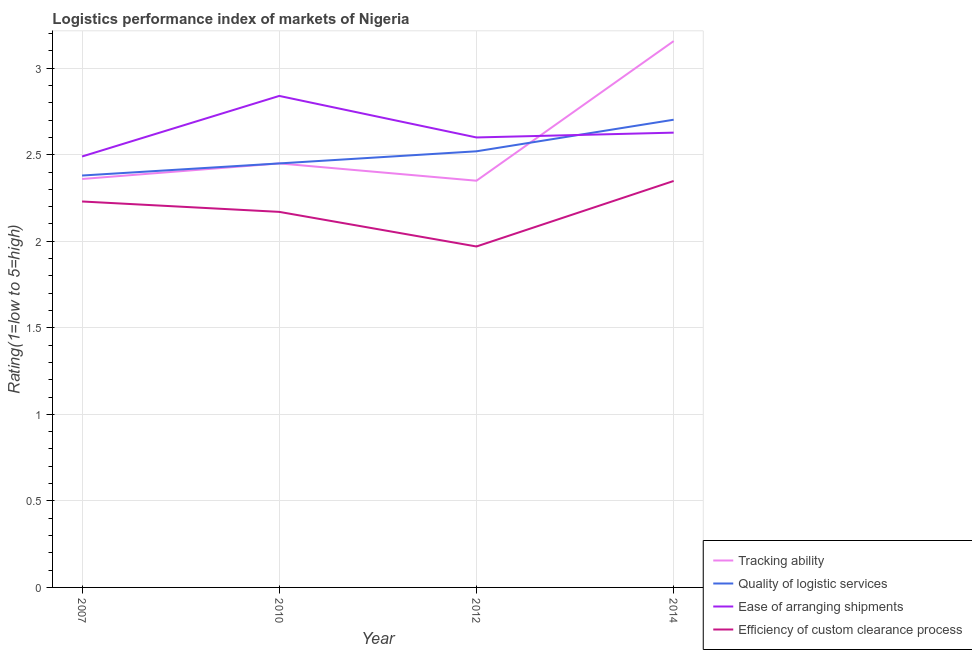What is the lpi rating of tracking ability in 2010?
Keep it short and to the point. 2.45. Across all years, what is the maximum lpi rating of quality of logistic services?
Ensure brevity in your answer.  2.7. Across all years, what is the minimum lpi rating of ease of arranging shipments?
Give a very brief answer. 2.49. In which year was the lpi rating of efficiency of custom clearance process maximum?
Give a very brief answer. 2014. In which year was the lpi rating of efficiency of custom clearance process minimum?
Your answer should be compact. 2012. What is the total lpi rating of ease of arranging shipments in the graph?
Give a very brief answer. 10.56. What is the difference between the lpi rating of quality of logistic services in 2012 and that in 2014?
Keep it short and to the point. -0.18. What is the difference between the lpi rating of efficiency of custom clearance process in 2014 and the lpi rating of ease of arranging shipments in 2007?
Make the answer very short. -0.14. What is the average lpi rating of tracking ability per year?
Give a very brief answer. 2.58. In the year 2014, what is the difference between the lpi rating of efficiency of custom clearance process and lpi rating of tracking ability?
Keep it short and to the point. -0.81. In how many years, is the lpi rating of efficiency of custom clearance process greater than 2?
Provide a succinct answer. 3. What is the ratio of the lpi rating of quality of logistic services in 2007 to that in 2014?
Offer a very short reply. 0.88. Is the lpi rating of tracking ability in 2007 less than that in 2010?
Ensure brevity in your answer.  Yes. Is the difference between the lpi rating of efficiency of custom clearance process in 2010 and 2012 greater than the difference between the lpi rating of ease of arranging shipments in 2010 and 2012?
Provide a succinct answer. No. What is the difference between the highest and the second highest lpi rating of quality of logistic services?
Give a very brief answer. 0.18. What is the difference between the highest and the lowest lpi rating of ease of arranging shipments?
Give a very brief answer. 0.35. Is the sum of the lpi rating of quality of logistic services in 2012 and 2014 greater than the maximum lpi rating of tracking ability across all years?
Your answer should be compact. Yes. Is the lpi rating of efficiency of custom clearance process strictly greater than the lpi rating of ease of arranging shipments over the years?
Ensure brevity in your answer.  No. How many lines are there?
Your answer should be very brief. 4. Does the graph contain any zero values?
Provide a succinct answer. No. How many legend labels are there?
Make the answer very short. 4. How are the legend labels stacked?
Offer a very short reply. Vertical. What is the title of the graph?
Provide a succinct answer. Logistics performance index of markets of Nigeria. Does "Belgium" appear as one of the legend labels in the graph?
Give a very brief answer. No. What is the label or title of the Y-axis?
Give a very brief answer. Rating(1=low to 5=high). What is the Rating(1=low to 5=high) in Tracking ability in 2007?
Make the answer very short. 2.36. What is the Rating(1=low to 5=high) in Quality of logistic services in 2007?
Give a very brief answer. 2.38. What is the Rating(1=low to 5=high) of Ease of arranging shipments in 2007?
Your response must be concise. 2.49. What is the Rating(1=low to 5=high) of Efficiency of custom clearance process in 2007?
Give a very brief answer. 2.23. What is the Rating(1=low to 5=high) in Tracking ability in 2010?
Ensure brevity in your answer.  2.45. What is the Rating(1=low to 5=high) of Quality of logistic services in 2010?
Your answer should be compact. 2.45. What is the Rating(1=low to 5=high) in Ease of arranging shipments in 2010?
Give a very brief answer. 2.84. What is the Rating(1=low to 5=high) of Efficiency of custom clearance process in 2010?
Ensure brevity in your answer.  2.17. What is the Rating(1=low to 5=high) in Tracking ability in 2012?
Make the answer very short. 2.35. What is the Rating(1=low to 5=high) of Quality of logistic services in 2012?
Give a very brief answer. 2.52. What is the Rating(1=low to 5=high) of Ease of arranging shipments in 2012?
Keep it short and to the point. 2.6. What is the Rating(1=low to 5=high) of Efficiency of custom clearance process in 2012?
Provide a succinct answer. 1.97. What is the Rating(1=low to 5=high) of Tracking ability in 2014?
Provide a short and direct response. 3.16. What is the Rating(1=low to 5=high) of Quality of logistic services in 2014?
Make the answer very short. 2.7. What is the Rating(1=low to 5=high) of Ease of arranging shipments in 2014?
Your answer should be compact. 2.63. What is the Rating(1=low to 5=high) of Efficiency of custom clearance process in 2014?
Offer a very short reply. 2.35. Across all years, what is the maximum Rating(1=low to 5=high) of Tracking ability?
Offer a very short reply. 3.16. Across all years, what is the maximum Rating(1=low to 5=high) of Quality of logistic services?
Your answer should be very brief. 2.7. Across all years, what is the maximum Rating(1=low to 5=high) in Ease of arranging shipments?
Your answer should be compact. 2.84. Across all years, what is the maximum Rating(1=low to 5=high) in Efficiency of custom clearance process?
Provide a succinct answer. 2.35. Across all years, what is the minimum Rating(1=low to 5=high) in Tracking ability?
Keep it short and to the point. 2.35. Across all years, what is the minimum Rating(1=low to 5=high) in Quality of logistic services?
Offer a very short reply. 2.38. Across all years, what is the minimum Rating(1=low to 5=high) of Ease of arranging shipments?
Provide a short and direct response. 2.49. Across all years, what is the minimum Rating(1=low to 5=high) in Efficiency of custom clearance process?
Keep it short and to the point. 1.97. What is the total Rating(1=low to 5=high) in Tracking ability in the graph?
Provide a short and direct response. 10.32. What is the total Rating(1=low to 5=high) of Quality of logistic services in the graph?
Your response must be concise. 10.05. What is the total Rating(1=low to 5=high) of Ease of arranging shipments in the graph?
Provide a short and direct response. 10.56. What is the total Rating(1=low to 5=high) of Efficiency of custom clearance process in the graph?
Give a very brief answer. 8.72. What is the difference between the Rating(1=low to 5=high) in Tracking ability in 2007 and that in 2010?
Offer a very short reply. -0.09. What is the difference between the Rating(1=low to 5=high) in Quality of logistic services in 2007 and that in 2010?
Your answer should be very brief. -0.07. What is the difference between the Rating(1=low to 5=high) in Ease of arranging shipments in 2007 and that in 2010?
Provide a succinct answer. -0.35. What is the difference between the Rating(1=low to 5=high) of Tracking ability in 2007 and that in 2012?
Offer a very short reply. 0.01. What is the difference between the Rating(1=low to 5=high) of Quality of logistic services in 2007 and that in 2012?
Provide a short and direct response. -0.14. What is the difference between the Rating(1=low to 5=high) in Ease of arranging shipments in 2007 and that in 2012?
Provide a short and direct response. -0.11. What is the difference between the Rating(1=low to 5=high) in Efficiency of custom clearance process in 2007 and that in 2012?
Your answer should be compact. 0.26. What is the difference between the Rating(1=low to 5=high) in Tracking ability in 2007 and that in 2014?
Give a very brief answer. -0.8. What is the difference between the Rating(1=low to 5=high) in Quality of logistic services in 2007 and that in 2014?
Give a very brief answer. -0.32. What is the difference between the Rating(1=low to 5=high) of Ease of arranging shipments in 2007 and that in 2014?
Give a very brief answer. -0.14. What is the difference between the Rating(1=low to 5=high) of Efficiency of custom clearance process in 2007 and that in 2014?
Offer a terse response. -0.12. What is the difference between the Rating(1=low to 5=high) in Quality of logistic services in 2010 and that in 2012?
Your answer should be very brief. -0.07. What is the difference between the Rating(1=low to 5=high) of Ease of arranging shipments in 2010 and that in 2012?
Your answer should be very brief. 0.24. What is the difference between the Rating(1=low to 5=high) in Efficiency of custom clearance process in 2010 and that in 2012?
Your answer should be very brief. 0.2. What is the difference between the Rating(1=low to 5=high) in Tracking ability in 2010 and that in 2014?
Provide a succinct answer. -0.71. What is the difference between the Rating(1=low to 5=high) of Quality of logistic services in 2010 and that in 2014?
Offer a terse response. -0.25. What is the difference between the Rating(1=low to 5=high) of Ease of arranging shipments in 2010 and that in 2014?
Your response must be concise. 0.21. What is the difference between the Rating(1=low to 5=high) in Efficiency of custom clearance process in 2010 and that in 2014?
Offer a terse response. -0.18. What is the difference between the Rating(1=low to 5=high) in Tracking ability in 2012 and that in 2014?
Give a very brief answer. -0.81. What is the difference between the Rating(1=low to 5=high) in Quality of logistic services in 2012 and that in 2014?
Provide a succinct answer. -0.18. What is the difference between the Rating(1=low to 5=high) in Ease of arranging shipments in 2012 and that in 2014?
Keep it short and to the point. -0.03. What is the difference between the Rating(1=low to 5=high) of Efficiency of custom clearance process in 2012 and that in 2014?
Offer a very short reply. -0.38. What is the difference between the Rating(1=low to 5=high) in Tracking ability in 2007 and the Rating(1=low to 5=high) in Quality of logistic services in 2010?
Offer a very short reply. -0.09. What is the difference between the Rating(1=low to 5=high) of Tracking ability in 2007 and the Rating(1=low to 5=high) of Ease of arranging shipments in 2010?
Your response must be concise. -0.48. What is the difference between the Rating(1=low to 5=high) in Tracking ability in 2007 and the Rating(1=low to 5=high) in Efficiency of custom clearance process in 2010?
Your answer should be very brief. 0.19. What is the difference between the Rating(1=low to 5=high) of Quality of logistic services in 2007 and the Rating(1=low to 5=high) of Ease of arranging shipments in 2010?
Offer a very short reply. -0.46. What is the difference between the Rating(1=low to 5=high) of Quality of logistic services in 2007 and the Rating(1=low to 5=high) of Efficiency of custom clearance process in 2010?
Your answer should be compact. 0.21. What is the difference between the Rating(1=low to 5=high) in Ease of arranging shipments in 2007 and the Rating(1=low to 5=high) in Efficiency of custom clearance process in 2010?
Your response must be concise. 0.32. What is the difference between the Rating(1=low to 5=high) in Tracking ability in 2007 and the Rating(1=low to 5=high) in Quality of logistic services in 2012?
Your response must be concise. -0.16. What is the difference between the Rating(1=low to 5=high) in Tracking ability in 2007 and the Rating(1=low to 5=high) in Ease of arranging shipments in 2012?
Make the answer very short. -0.24. What is the difference between the Rating(1=low to 5=high) of Tracking ability in 2007 and the Rating(1=low to 5=high) of Efficiency of custom clearance process in 2012?
Give a very brief answer. 0.39. What is the difference between the Rating(1=low to 5=high) of Quality of logistic services in 2007 and the Rating(1=low to 5=high) of Ease of arranging shipments in 2012?
Make the answer very short. -0.22. What is the difference between the Rating(1=low to 5=high) in Quality of logistic services in 2007 and the Rating(1=low to 5=high) in Efficiency of custom clearance process in 2012?
Make the answer very short. 0.41. What is the difference between the Rating(1=low to 5=high) in Ease of arranging shipments in 2007 and the Rating(1=low to 5=high) in Efficiency of custom clearance process in 2012?
Provide a succinct answer. 0.52. What is the difference between the Rating(1=low to 5=high) in Tracking ability in 2007 and the Rating(1=low to 5=high) in Quality of logistic services in 2014?
Provide a short and direct response. -0.34. What is the difference between the Rating(1=low to 5=high) of Tracking ability in 2007 and the Rating(1=low to 5=high) of Ease of arranging shipments in 2014?
Ensure brevity in your answer.  -0.27. What is the difference between the Rating(1=low to 5=high) of Tracking ability in 2007 and the Rating(1=low to 5=high) of Efficiency of custom clearance process in 2014?
Give a very brief answer. 0.01. What is the difference between the Rating(1=low to 5=high) in Quality of logistic services in 2007 and the Rating(1=low to 5=high) in Ease of arranging shipments in 2014?
Give a very brief answer. -0.25. What is the difference between the Rating(1=low to 5=high) in Quality of logistic services in 2007 and the Rating(1=low to 5=high) in Efficiency of custom clearance process in 2014?
Your answer should be very brief. 0.03. What is the difference between the Rating(1=low to 5=high) of Ease of arranging shipments in 2007 and the Rating(1=low to 5=high) of Efficiency of custom clearance process in 2014?
Provide a succinct answer. 0.14. What is the difference between the Rating(1=low to 5=high) in Tracking ability in 2010 and the Rating(1=low to 5=high) in Quality of logistic services in 2012?
Your response must be concise. -0.07. What is the difference between the Rating(1=low to 5=high) in Tracking ability in 2010 and the Rating(1=low to 5=high) in Ease of arranging shipments in 2012?
Your answer should be compact. -0.15. What is the difference between the Rating(1=low to 5=high) of Tracking ability in 2010 and the Rating(1=low to 5=high) of Efficiency of custom clearance process in 2012?
Keep it short and to the point. 0.48. What is the difference between the Rating(1=low to 5=high) in Quality of logistic services in 2010 and the Rating(1=low to 5=high) in Efficiency of custom clearance process in 2012?
Provide a succinct answer. 0.48. What is the difference between the Rating(1=low to 5=high) in Ease of arranging shipments in 2010 and the Rating(1=low to 5=high) in Efficiency of custom clearance process in 2012?
Offer a terse response. 0.87. What is the difference between the Rating(1=low to 5=high) in Tracking ability in 2010 and the Rating(1=low to 5=high) in Quality of logistic services in 2014?
Your answer should be very brief. -0.25. What is the difference between the Rating(1=low to 5=high) in Tracking ability in 2010 and the Rating(1=low to 5=high) in Ease of arranging shipments in 2014?
Give a very brief answer. -0.18. What is the difference between the Rating(1=low to 5=high) of Tracking ability in 2010 and the Rating(1=low to 5=high) of Efficiency of custom clearance process in 2014?
Make the answer very short. 0.1. What is the difference between the Rating(1=low to 5=high) of Quality of logistic services in 2010 and the Rating(1=low to 5=high) of Ease of arranging shipments in 2014?
Give a very brief answer. -0.18. What is the difference between the Rating(1=low to 5=high) in Quality of logistic services in 2010 and the Rating(1=low to 5=high) in Efficiency of custom clearance process in 2014?
Ensure brevity in your answer.  0.1. What is the difference between the Rating(1=low to 5=high) in Ease of arranging shipments in 2010 and the Rating(1=low to 5=high) in Efficiency of custom clearance process in 2014?
Make the answer very short. 0.49. What is the difference between the Rating(1=low to 5=high) in Tracking ability in 2012 and the Rating(1=low to 5=high) in Quality of logistic services in 2014?
Make the answer very short. -0.35. What is the difference between the Rating(1=low to 5=high) in Tracking ability in 2012 and the Rating(1=low to 5=high) in Ease of arranging shipments in 2014?
Your response must be concise. -0.28. What is the difference between the Rating(1=low to 5=high) in Tracking ability in 2012 and the Rating(1=low to 5=high) in Efficiency of custom clearance process in 2014?
Your answer should be compact. 0. What is the difference between the Rating(1=low to 5=high) in Quality of logistic services in 2012 and the Rating(1=low to 5=high) in Ease of arranging shipments in 2014?
Your response must be concise. -0.11. What is the difference between the Rating(1=low to 5=high) of Quality of logistic services in 2012 and the Rating(1=low to 5=high) of Efficiency of custom clearance process in 2014?
Ensure brevity in your answer.  0.17. What is the difference between the Rating(1=low to 5=high) in Ease of arranging shipments in 2012 and the Rating(1=low to 5=high) in Efficiency of custom clearance process in 2014?
Offer a terse response. 0.25. What is the average Rating(1=low to 5=high) of Tracking ability per year?
Your answer should be very brief. 2.58. What is the average Rating(1=low to 5=high) of Quality of logistic services per year?
Your answer should be compact. 2.51. What is the average Rating(1=low to 5=high) of Ease of arranging shipments per year?
Your answer should be compact. 2.64. What is the average Rating(1=low to 5=high) in Efficiency of custom clearance process per year?
Provide a short and direct response. 2.18. In the year 2007, what is the difference between the Rating(1=low to 5=high) in Tracking ability and Rating(1=low to 5=high) in Quality of logistic services?
Offer a very short reply. -0.02. In the year 2007, what is the difference between the Rating(1=low to 5=high) in Tracking ability and Rating(1=low to 5=high) in Ease of arranging shipments?
Ensure brevity in your answer.  -0.13. In the year 2007, what is the difference between the Rating(1=low to 5=high) in Tracking ability and Rating(1=low to 5=high) in Efficiency of custom clearance process?
Ensure brevity in your answer.  0.13. In the year 2007, what is the difference between the Rating(1=low to 5=high) in Quality of logistic services and Rating(1=low to 5=high) in Ease of arranging shipments?
Offer a terse response. -0.11. In the year 2007, what is the difference between the Rating(1=low to 5=high) of Ease of arranging shipments and Rating(1=low to 5=high) of Efficiency of custom clearance process?
Offer a terse response. 0.26. In the year 2010, what is the difference between the Rating(1=low to 5=high) of Tracking ability and Rating(1=low to 5=high) of Quality of logistic services?
Give a very brief answer. 0. In the year 2010, what is the difference between the Rating(1=low to 5=high) of Tracking ability and Rating(1=low to 5=high) of Ease of arranging shipments?
Provide a short and direct response. -0.39. In the year 2010, what is the difference between the Rating(1=low to 5=high) of Tracking ability and Rating(1=low to 5=high) of Efficiency of custom clearance process?
Your answer should be compact. 0.28. In the year 2010, what is the difference between the Rating(1=low to 5=high) in Quality of logistic services and Rating(1=low to 5=high) in Ease of arranging shipments?
Provide a short and direct response. -0.39. In the year 2010, what is the difference between the Rating(1=low to 5=high) of Quality of logistic services and Rating(1=low to 5=high) of Efficiency of custom clearance process?
Offer a very short reply. 0.28. In the year 2010, what is the difference between the Rating(1=low to 5=high) of Ease of arranging shipments and Rating(1=low to 5=high) of Efficiency of custom clearance process?
Make the answer very short. 0.67. In the year 2012, what is the difference between the Rating(1=low to 5=high) of Tracking ability and Rating(1=low to 5=high) of Quality of logistic services?
Provide a short and direct response. -0.17. In the year 2012, what is the difference between the Rating(1=low to 5=high) of Tracking ability and Rating(1=low to 5=high) of Ease of arranging shipments?
Ensure brevity in your answer.  -0.25. In the year 2012, what is the difference between the Rating(1=low to 5=high) of Tracking ability and Rating(1=low to 5=high) of Efficiency of custom clearance process?
Give a very brief answer. 0.38. In the year 2012, what is the difference between the Rating(1=low to 5=high) in Quality of logistic services and Rating(1=low to 5=high) in Ease of arranging shipments?
Your answer should be very brief. -0.08. In the year 2012, what is the difference between the Rating(1=low to 5=high) in Quality of logistic services and Rating(1=low to 5=high) in Efficiency of custom clearance process?
Make the answer very short. 0.55. In the year 2012, what is the difference between the Rating(1=low to 5=high) of Ease of arranging shipments and Rating(1=low to 5=high) of Efficiency of custom clearance process?
Provide a succinct answer. 0.63. In the year 2014, what is the difference between the Rating(1=low to 5=high) in Tracking ability and Rating(1=low to 5=high) in Quality of logistic services?
Your answer should be compact. 0.45. In the year 2014, what is the difference between the Rating(1=low to 5=high) in Tracking ability and Rating(1=low to 5=high) in Ease of arranging shipments?
Offer a terse response. 0.53. In the year 2014, what is the difference between the Rating(1=low to 5=high) of Tracking ability and Rating(1=low to 5=high) of Efficiency of custom clearance process?
Your response must be concise. 0.81. In the year 2014, what is the difference between the Rating(1=low to 5=high) in Quality of logistic services and Rating(1=low to 5=high) in Ease of arranging shipments?
Give a very brief answer. 0.07. In the year 2014, what is the difference between the Rating(1=low to 5=high) of Quality of logistic services and Rating(1=low to 5=high) of Efficiency of custom clearance process?
Make the answer very short. 0.35. In the year 2014, what is the difference between the Rating(1=low to 5=high) in Ease of arranging shipments and Rating(1=low to 5=high) in Efficiency of custom clearance process?
Provide a succinct answer. 0.28. What is the ratio of the Rating(1=low to 5=high) in Tracking ability in 2007 to that in 2010?
Provide a short and direct response. 0.96. What is the ratio of the Rating(1=low to 5=high) of Quality of logistic services in 2007 to that in 2010?
Your answer should be very brief. 0.97. What is the ratio of the Rating(1=low to 5=high) of Ease of arranging shipments in 2007 to that in 2010?
Make the answer very short. 0.88. What is the ratio of the Rating(1=low to 5=high) in Efficiency of custom clearance process in 2007 to that in 2010?
Offer a very short reply. 1.03. What is the ratio of the Rating(1=low to 5=high) of Quality of logistic services in 2007 to that in 2012?
Ensure brevity in your answer.  0.94. What is the ratio of the Rating(1=low to 5=high) in Ease of arranging shipments in 2007 to that in 2012?
Ensure brevity in your answer.  0.96. What is the ratio of the Rating(1=low to 5=high) in Efficiency of custom clearance process in 2007 to that in 2012?
Your response must be concise. 1.13. What is the ratio of the Rating(1=low to 5=high) of Tracking ability in 2007 to that in 2014?
Offer a terse response. 0.75. What is the ratio of the Rating(1=low to 5=high) in Quality of logistic services in 2007 to that in 2014?
Offer a terse response. 0.88. What is the ratio of the Rating(1=low to 5=high) in Ease of arranging shipments in 2007 to that in 2014?
Make the answer very short. 0.95. What is the ratio of the Rating(1=low to 5=high) of Efficiency of custom clearance process in 2007 to that in 2014?
Ensure brevity in your answer.  0.95. What is the ratio of the Rating(1=low to 5=high) of Tracking ability in 2010 to that in 2012?
Your response must be concise. 1.04. What is the ratio of the Rating(1=low to 5=high) in Quality of logistic services in 2010 to that in 2012?
Your answer should be compact. 0.97. What is the ratio of the Rating(1=low to 5=high) in Ease of arranging shipments in 2010 to that in 2012?
Offer a terse response. 1.09. What is the ratio of the Rating(1=low to 5=high) of Efficiency of custom clearance process in 2010 to that in 2012?
Your answer should be very brief. 1.1. What is the ratio of the Rating(1=low to 5=high) in Tracking ability in 2010 to that in 2014?
Provide a succinct answer. 0.78. What is the ratio of the Rating(1=low to 5=high) in Quality of logistic services in 2010 to that in 2014?
Ensure brevity in your answer.  0.91. What is the ratio of the Rating(1=low to 5=high) in Ease of arranging shipments in 2010 to that in 2014?
Give a very brief answer. 1.08. What is the ratio of the Rating(1=low to 5=high) of Efficiency of custom clearance process in 2010 to that in 2014?
Offer a terse response. 0.92. What is the ratio of the Rating(1=low to 5=high) in Tracking ability in 2012 to that in 2014?
Make the answer very short. 0.74. What is the ratio of the Rating(1=low to 5=high) in Quality of logistic services in 2012 to that in 2014?
Ensure brevity in your answer.  0.93. What is the ratio of the Rating(1=low to 5=high) of Efficiency of custom clearance process in 2012 to that in 2014?
Your answer should be very brief. 0.84. What is the difference between the highest and the second highest Rating(1=low to 5=high) of Tracking ability?
Keep it short and to the point. 0.71. What is the difference between the highest and the second highest Rating(1=low to 5=high) of Quality of logistic services?
Your answer should be very brief. 0.18. What is the difference between the highest and the second highest Rating(1=low to 5=high) of Ease of arranging shipments?
Your answer should be compact. 0.21. What is the difference between the highest and the second highest Rating(1=low to 5=high) of Efficiency of custom clearance process?
Provide a succinct answer. 0.12. What is the difference between the highest and the lowest Rating(1=low to 5=high) of Tracking ability?
Give a very brief answer. 0.81. What is the difference between the highest and the lowest Rating(1=low to 5=high) in Quality of logistic services?
Keep it short and to the point. 0.32. What is the difference between the highest and the lowest Rating(1=low to 5=high) of Efficiency of custom clearance process?
Provide a short and direct response. 0.38. 